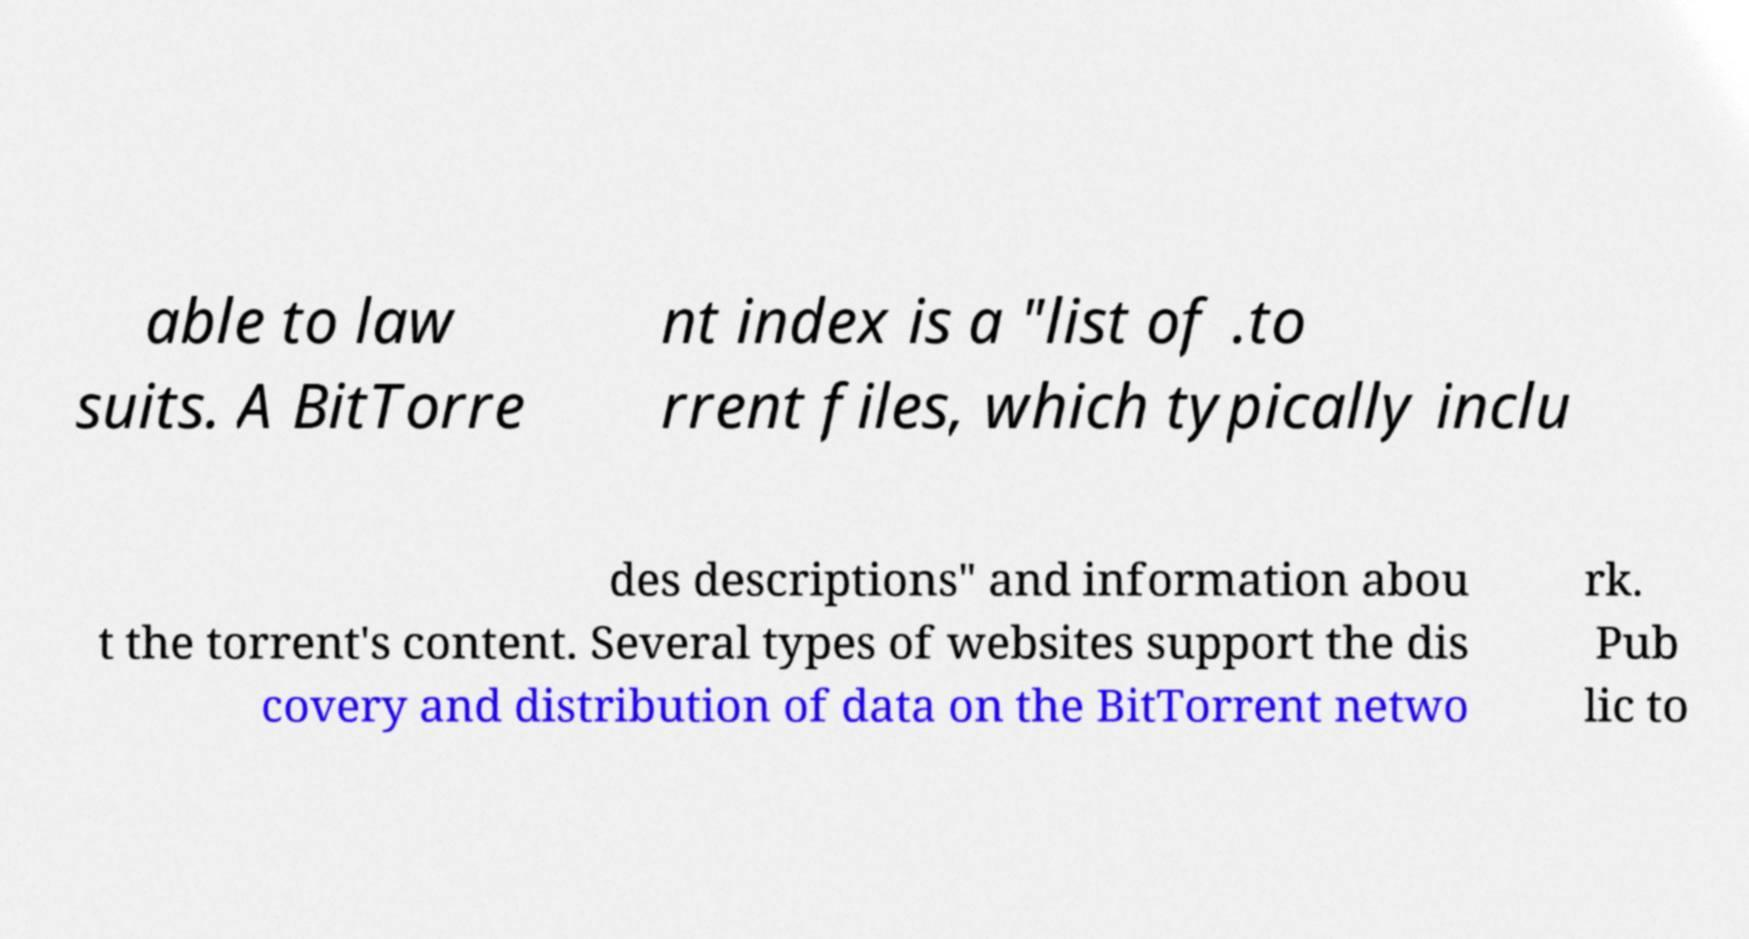Could you extract and type out the text from this image? able to law suits. A BitTorre nt index is a "list of .to rrent files, which typically inclu des descriptions" and information abou t the torrent's content. Several types of websites support the dis covery and distribution of data on the BitTorrent netwo rk. Pub lic to 